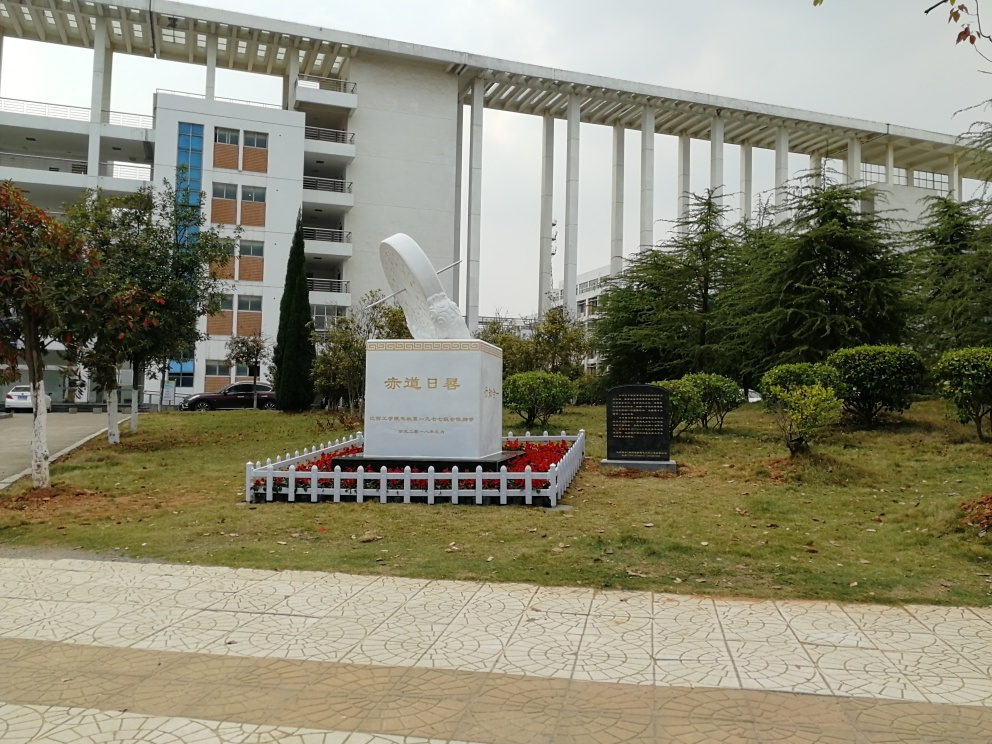What is the condition of the building in the image? The building in the image appears to be in good condition, retaining most of its texture and detail. There is no sign of major wear or structural damage on the visible facades, and the architectural lines remain crisp and clear amidst the surrounding greenery and open space. 